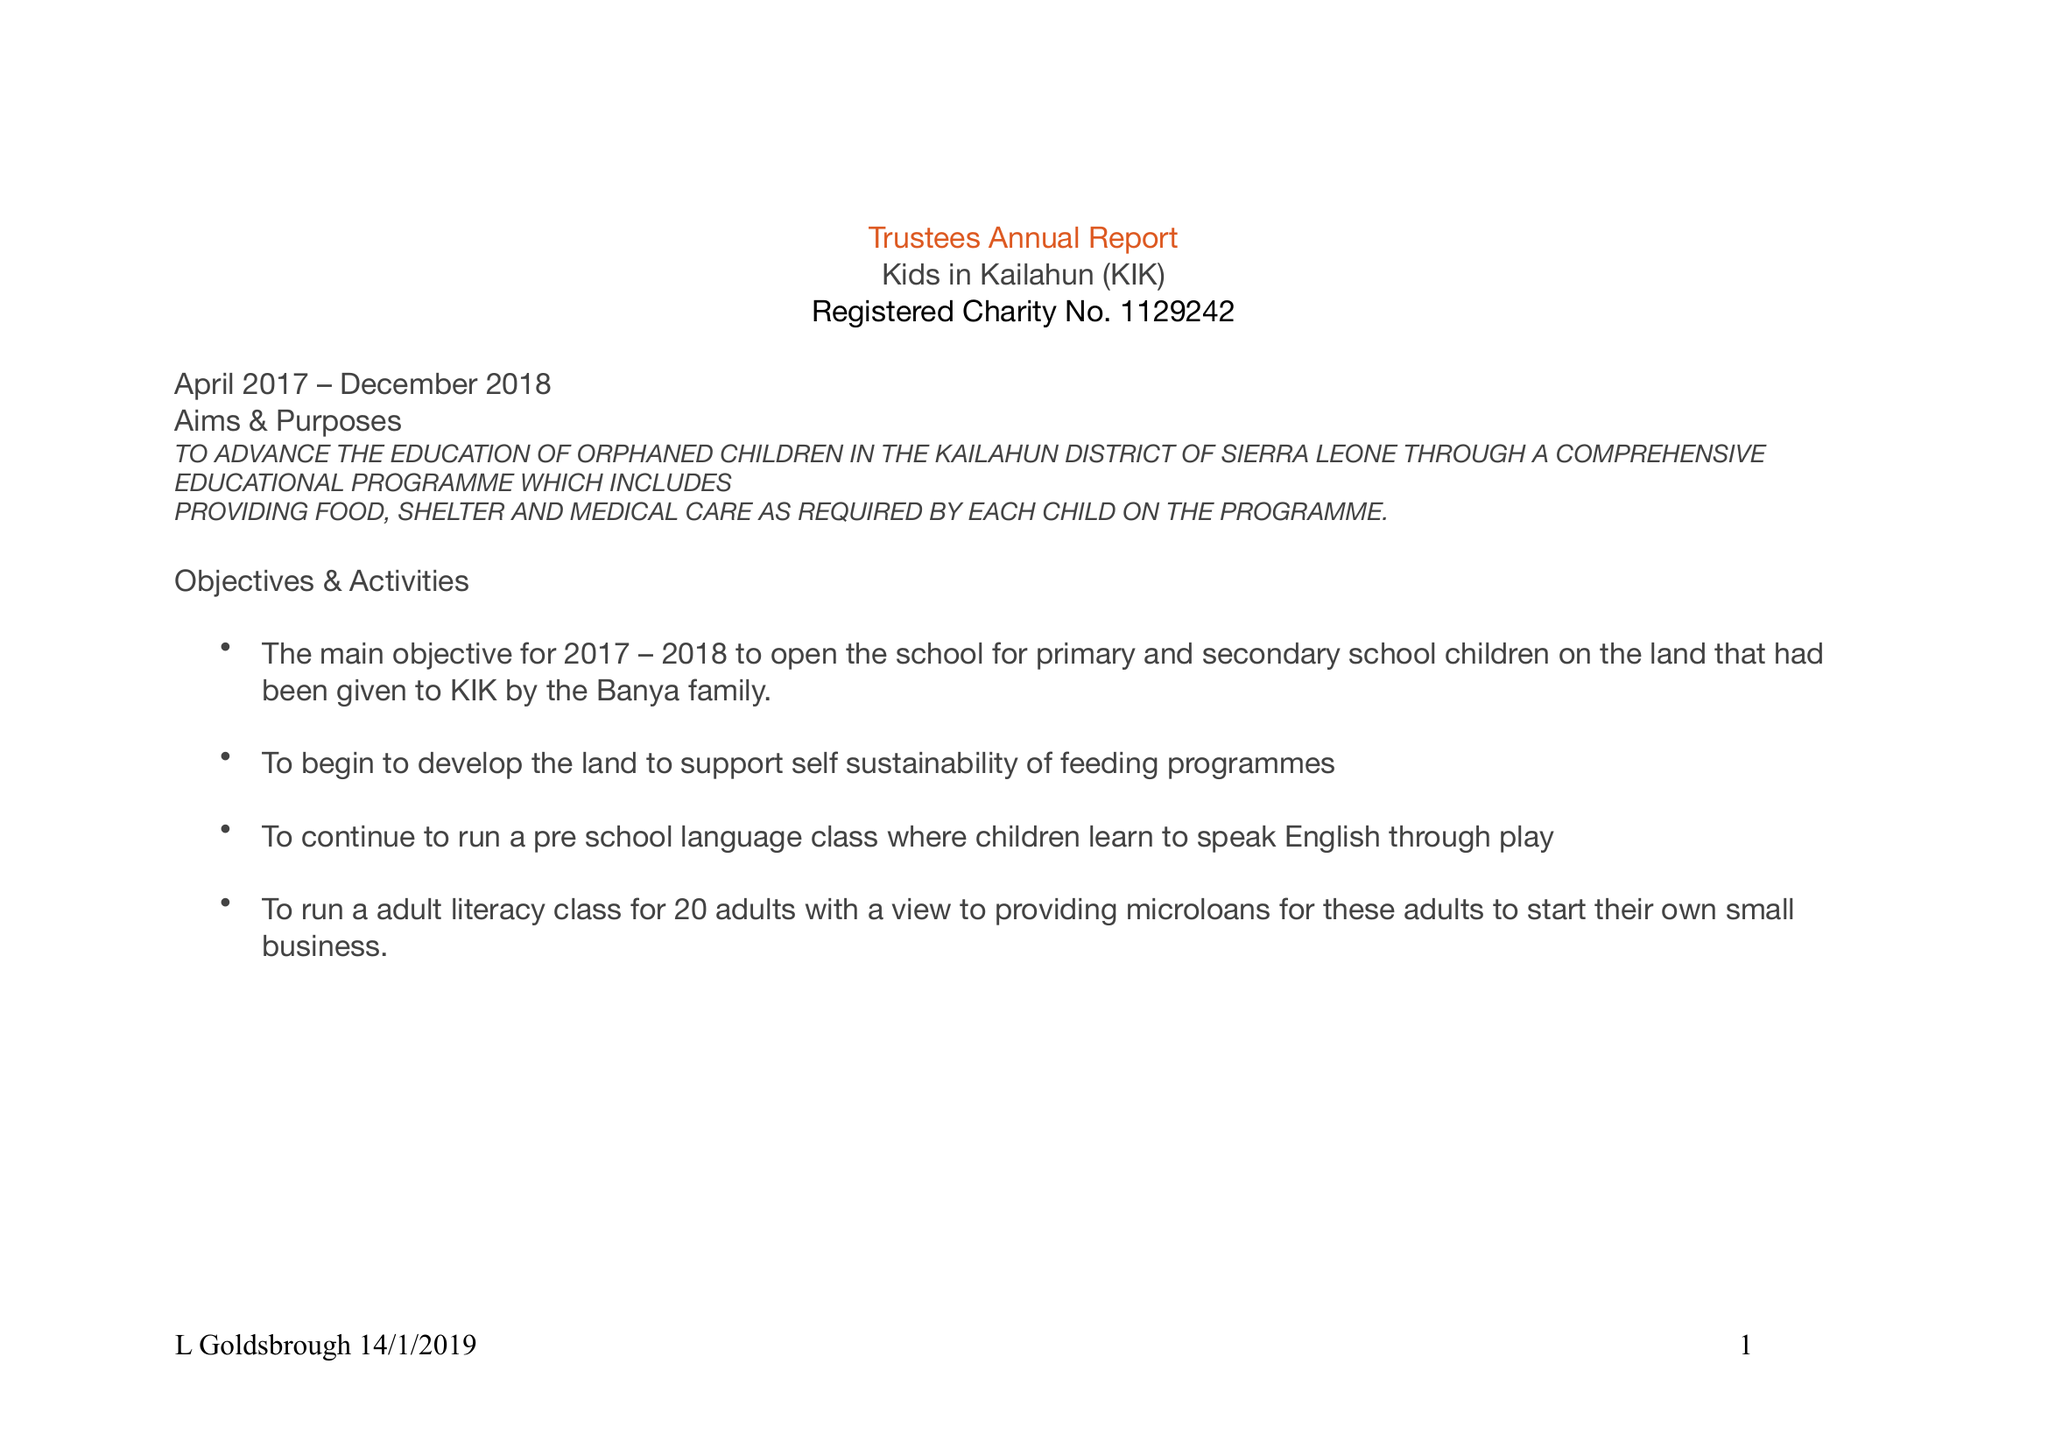What is the value for the charity_name?
Answer the question using a single word or phrase. Kids In Kailahun 